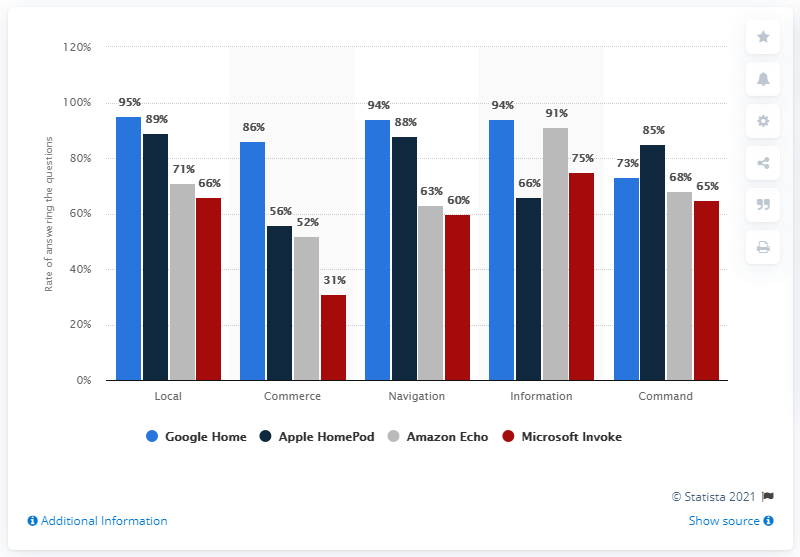Give some essential details in this illustration. According to a survey, the highest percentage of Google Home and Apple HomePod usage in navigation purposes is 48%. However, Google Home is more commonly used for this purpose, while Apple HomePod has a lower usage rate. According to data, the usage of Google Home speakers in commerce is at 86%. 